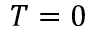<formula> <loc_0><loc_0><loc_500><loc_500>T = 0</formula> 